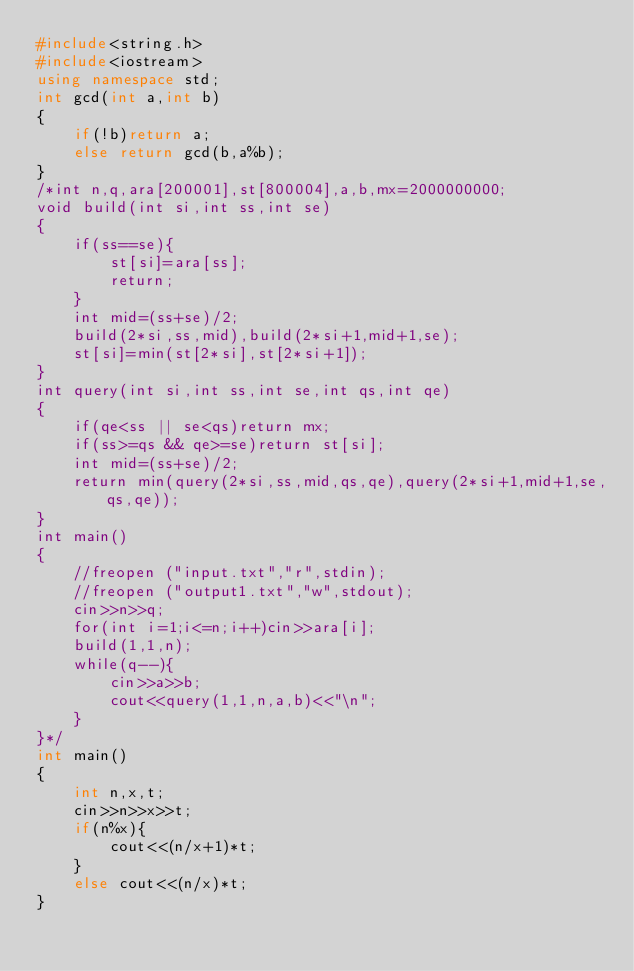<code> <loc_0><loc_0><loc_500><loc_500><_C++_>#include<string.h>
#include<iostream>
using namespace std;
int gcd(int a,int b)
{
    if(!b)return a;
    else return gcd(b,a%b);
}
/*int n,q,ara[200001],st[800004],a,b,mx=2000000000;
void build(int si,int ss,int se)
{
    if(ss==se){
        st[si]=ara[ss];
        return;
    }
    int mid=(ss+se)/2;
    build(2*si,ss,mid),build(2*si+1,mid+1,se);
    st[si]=min(st[2*si],st[2*si+1]);
}
int query(int si,int ss,int se,int qs,int qe)
{
    if(qe<ss || se<qs)return mx;
    if(ss>=qs && qe>=se)return st[si];
    int mid=(ss+se)/2;
    return min(query(2*si,ss,mid,qs,qe),query(2*si+1,mid+1,se,qs,qe));
}
int main()
{
    //freopen ("input.txt","r",stdin);
    //freopen ("output1.txt","w",stdout);
    cin>>n>>q;
    for(int i=1;i<=n;i++)cin>>ara[i];
    build(1,1,n);
    while(q--){
        cin>>a>>b;
        cout<<query(1,1,n,a,b)<<"\n";
    }
}*/
int main()
{
    int n,x,t;
    cin>>n>>x>>t;
    if(n%x){
        cout<<(n/x+1)*t;
    }
    else cout<<(n/x)*t;
}
</code> 